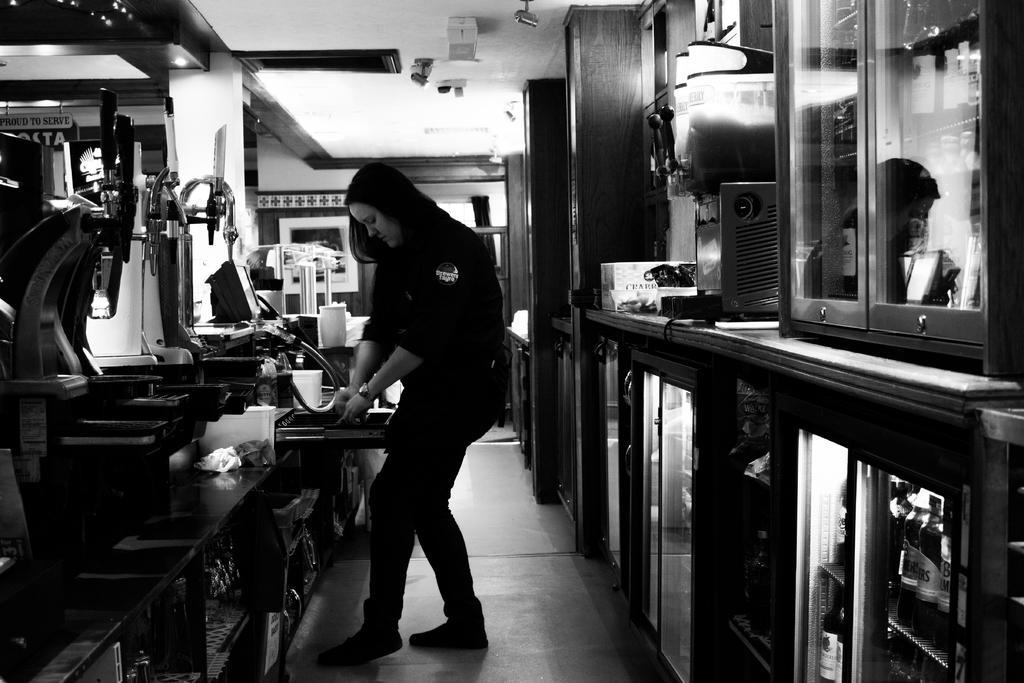Can you describe this image briefly? In this image I can see in the middle a woman is standing, on the left side there are machines. On the right side it looks like there are refrigerators. 